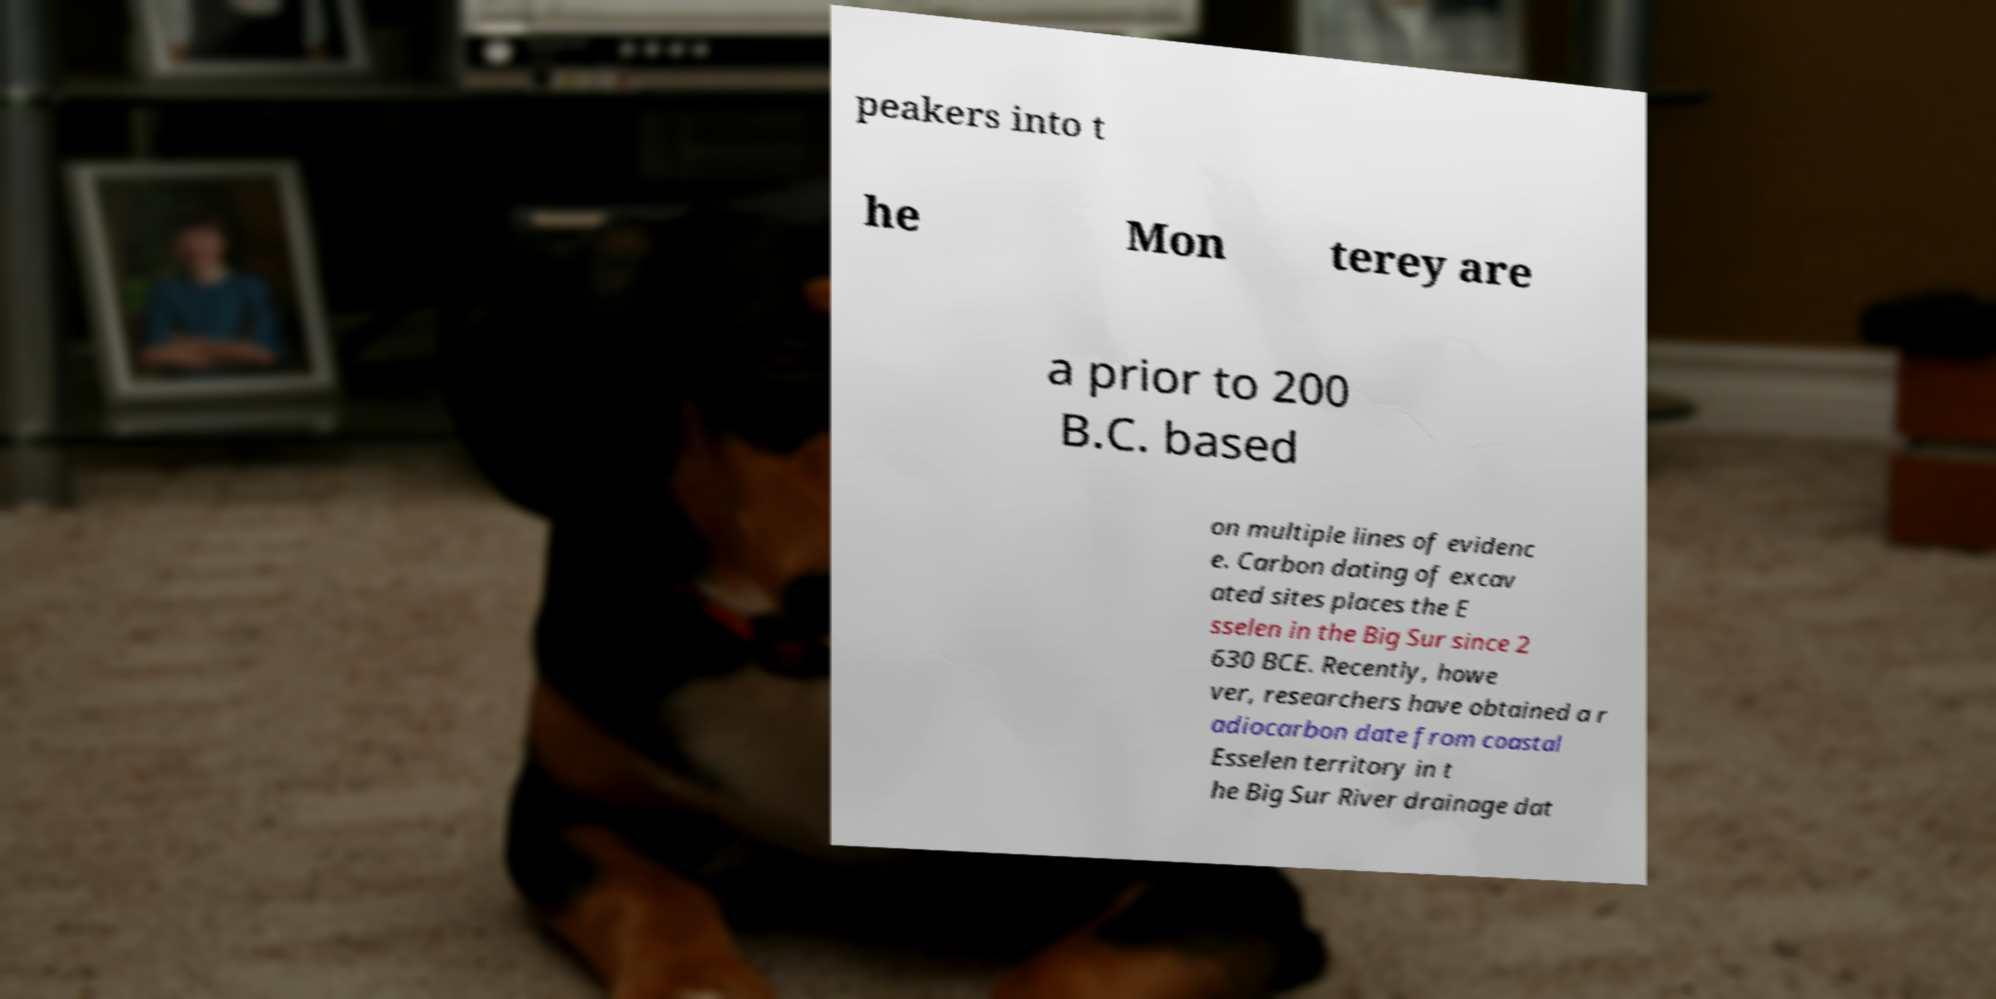Please identify and transcribe the text found in this image. peakers into t he Mon terey are a prior to 200 B.C. based on multiple lines of evidenc e. Carbon dating of excav ated sites places the E sselen in the Big Sur since 2 630 BCE. Recently, howe ver, researchers have obtained a r adiocarbon date from coastal Esselen territory in t he Big Sur River drainage dat 